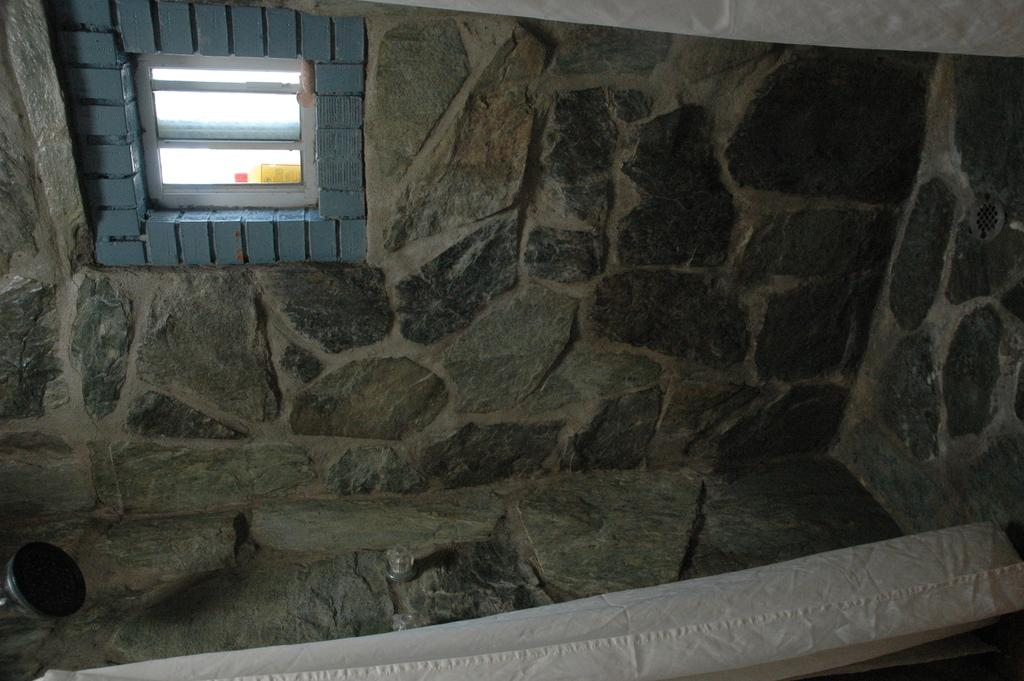What can be seen on the wall in the image? There is a wall with a window in the image. What is located on the left side of the image? There is an object on the left side of the image. What type of window treatment is present in the image? There are curtains at the top and bottom of the image. How many planes are flying in the image? There are no planes visible in the image. What type of underwear is hanging on the wall in the image? There is no underwear present in the image. 